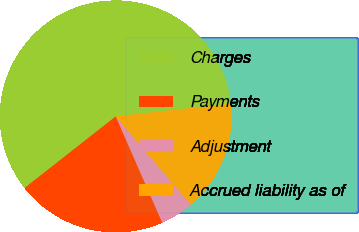<chart> <loc_0><loc_0><loc_500><loc_500><pie_chart><fcel>Charges<fcel>Payments<fcel>Adjustment<fcel>Accrued liability as of<nl><fcel>58.84%<fcel>20.97%<fcel>4.64%<fcel>15.55%<nl></chart> 